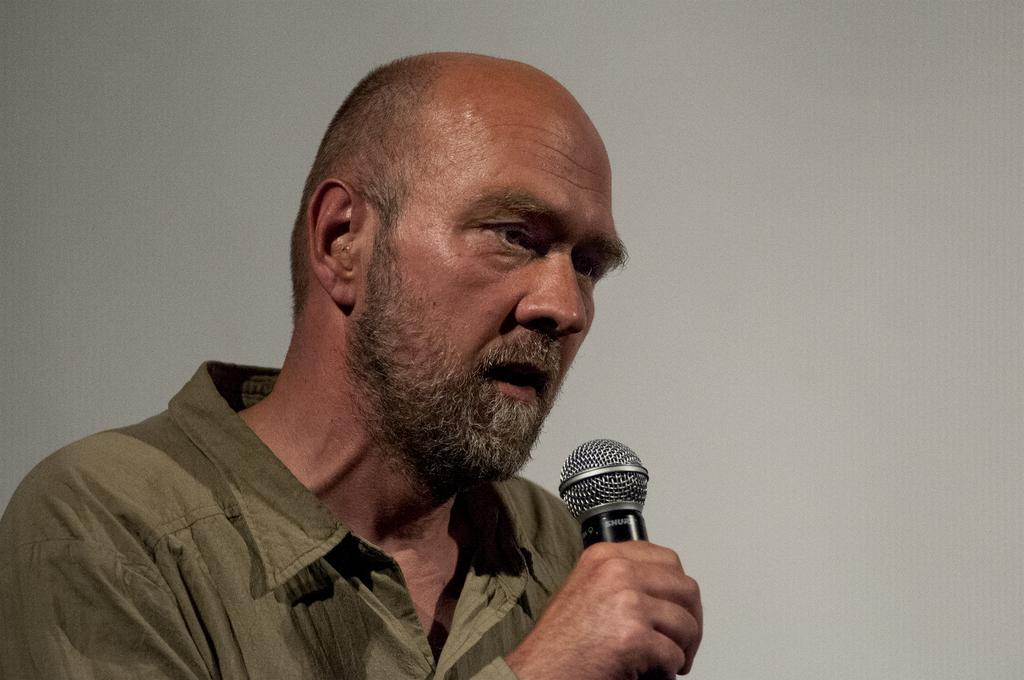What is the main subject of the image? There is a man in the image. What is the man doing in the image? The man is speaking in the image. What tool is the man using while speaking? The man is using a microphone in the image. What type of history can be seen in the background of the image? There is no history visible in the image; it only features a man speaking with a microphone. What type of loaf is the man holding in the image? There is no loaf present in the image; the man is using a microphone while speaking. 